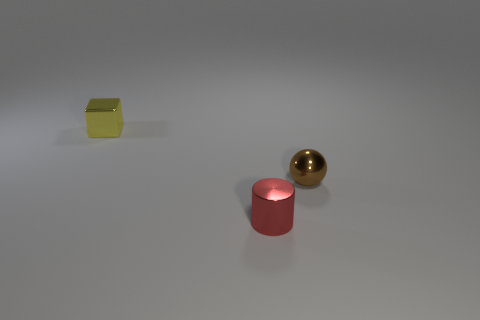Is the material of the small object that is right of the red metallic cylinder the same as the tiny thing in front of the brown sphere?
Offer a terse response. Yes. There is a small block; is its color the same as the shiny thing in front of the small brown thing?
Provide a succinct answer. No. What shape is the tiny brown thing?
Give a very brief answer. Sphere. Is the color of the metallic sphere the same as the small shiny cube?
Your answer should be very brief. No. How many things are shiny things left of the red cylinder or big blue rubber things?
Give a very brief answer. 1. What size is the brown object that is the same material as the red cylinder?
Provide a succinct answer. Small. Is the number of metallic cylinders on the left side of the tiny brown sphere greater than the number of brown metallic objects?
Provide a short and direct response. No. There is a brown metal thing; is its shape the same as the small metal object that is to the left of the red metal cylinder?
Your answer should be compact. No. How many big objects are either red cylinders or brown balls?
Your answer should be very brief. 0. What is the color of the tiny object on the right side of the shiny thing that is in front of the tiny brown object?
Ensure brevity in your answer.  Brown. 